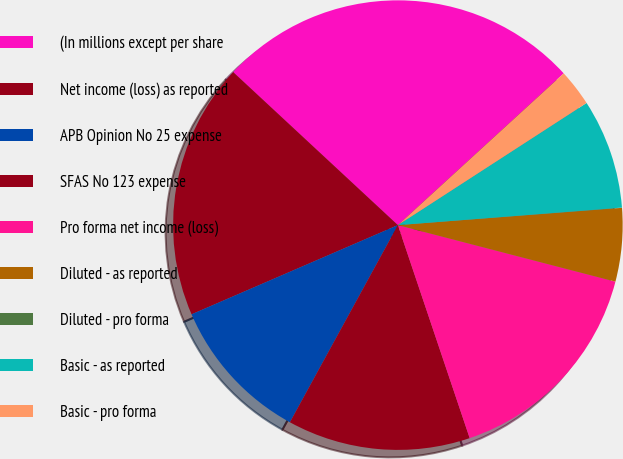Convert chart to OTSL. <chart><loc_0><loc_0><loc_500><loc_500><pie_chart><fcel>(In millions except per share<fcel>Net income (loss) as reported<fcel>APB Opinion No 25 expense<fcel>SFAS No 123 expense<fcel>Pro forma net income (loss)<fcel>Diluted - as reported<fcel>Diluted - pro forma<fcel>Basic - as reported<fcel>Basic - pro forma<nl><fcel>26.29%<fcel>18.41%<fcel>10.53%<fcel>13.15%<fcel>15.78%<fcel>5.27%<fcel>0.02%<fcel>7.9%<fcel>2.65%<nl></chart> 